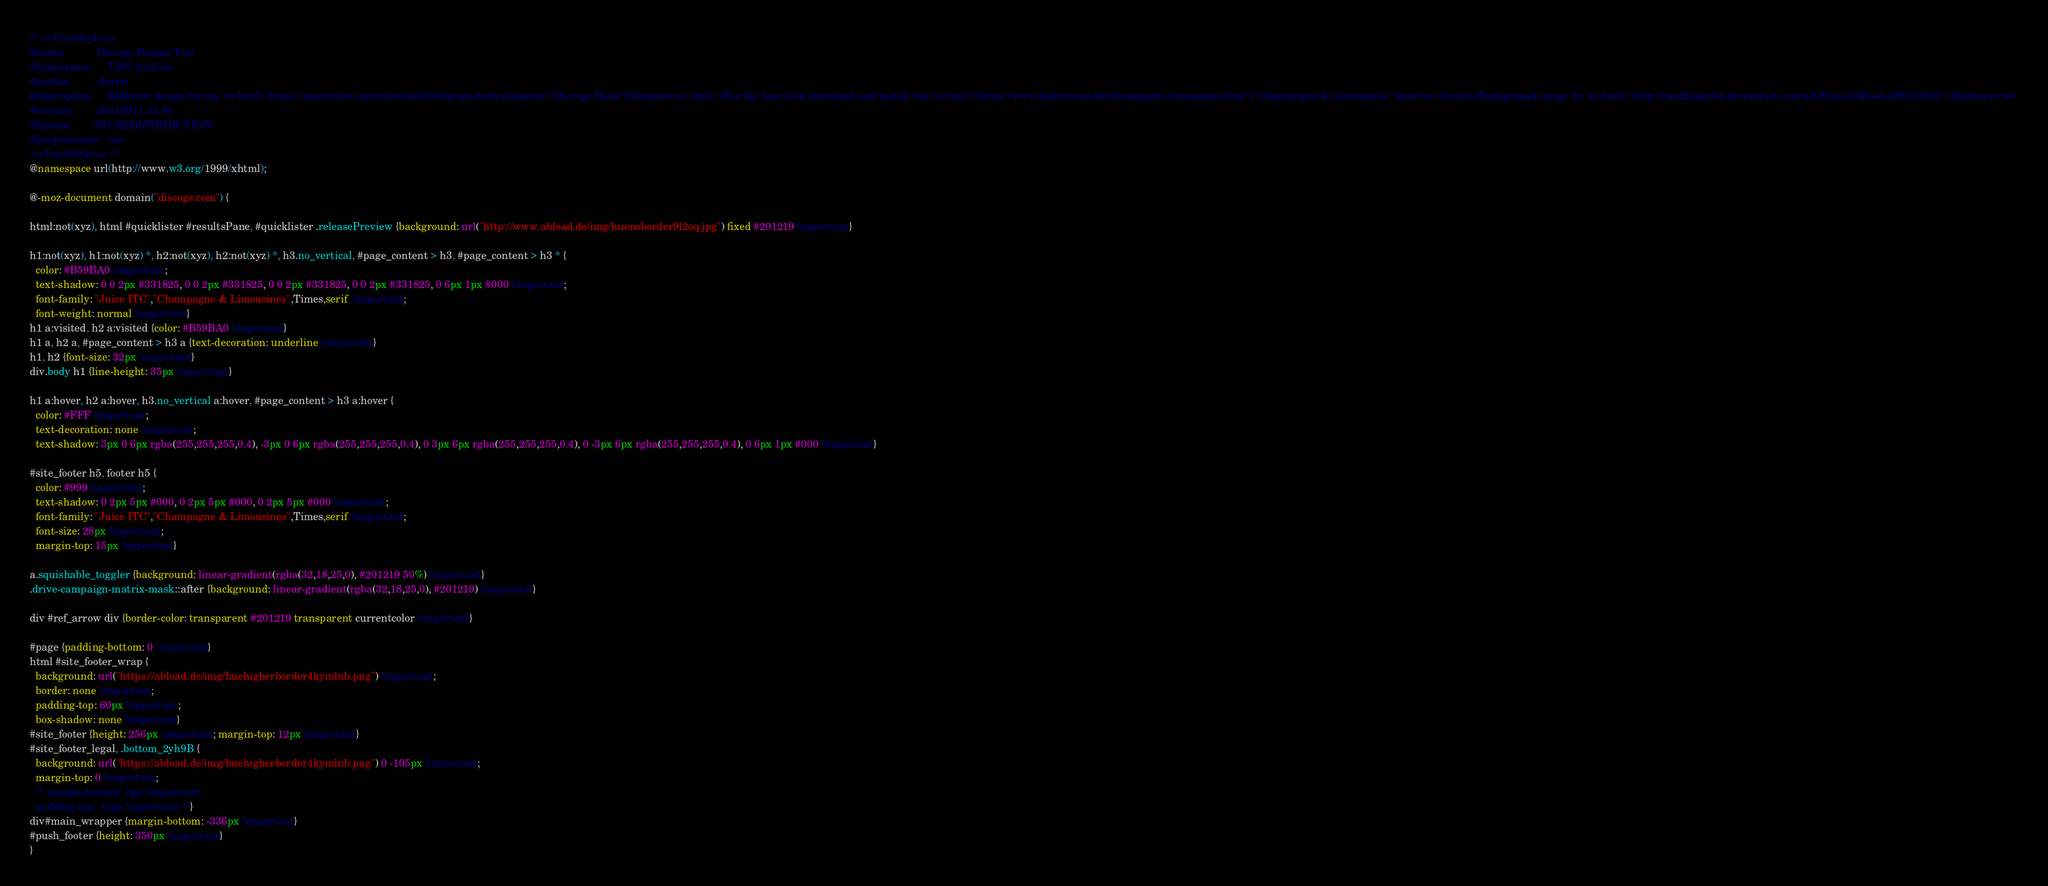<code> <loc_0><loc_0><loc_500><loc_500><_CSS_>/* ==UserStyle==
@name           Discogs Design Test
@namespace      USO Archive
@author         stormi
@description    `Different design for my <a href="https://userstyles.org/styles/44530/discogs-dark-ultimate">Discogs Dark Ultimate</a> style :)For the best look download and install the <a href="https://www.dafont.com/de/champagne-limousines.font">"Champagne & Limousines" font</a> Credits:Background image by <a href="http://vanillasky84.deviantart.com/art/Hue-of-Blood-268118623">Zurbaua</a>`
@version        20210911.13.48
@license        NO-REDISTRIBUTION
@preprocessor   uso
==/UserStyle== */
@namespace url(http://www.w3.org/1999/xhtml);

@-moz-document domain("discogs.com") {

html:not(xyz), html #quicklister #resultsPane, #quicklister .releasePreview {background: url("http://www.abload.de/img/huenoborder9l2oq.jpg") fixed #201219 !important}

h1:not(xyz), h1:not(xyz) *, h2:not(xyz), h2:not(xyz) *, h3.no_vertical, #page_content > h3, #page_content > h3 * {
  color: #B59BA0 !important;
  text-shadow: 0 0 2px #331825, 0 0 2px #331825, 0 0 2px #331825, 0 0 2px #331825, 0 6px 1px #000 !important;
  font-family: "Juice ITC","Champagne & Limousines",Times,serif !important;
  font-weight: normal !important}
h1 a:visited, h2 a:visited {color: #B59BA0 !important}
h1 a, h2 a, #page_content > h3 a {text-decoration: underline !important}
h1, h2 {font-size: 32px !important}
div.body h1 {line-height: 35px !important}

h1 a:hover, h2 a:hover, h3.no_vertical a:hover, #page_content > h3 a:hover {
  color: #FFF !important;
  text-decoration: none !important;
  text-shadow: 3px 0 6px rgba(255,255,255,0.4), -3px 0 6px rgba(255,255,255,0.4), 0 3px 6px rgba(255,255,255,0.4), 0 -3px 6px rgba(255,255,255,0.4), 0 6px 1px #000 !important}

#site_footer h5, footer h5 {
  color: #999 !important;
  text-shadow: 0 2px 5px #000, 0 2px 5px #000, 0 2px 5px #000 !important;
  font-family: "Juice ITC","Champagne & Limousines",Times,serif !important;
  font-size: 28px !important;
  margin-top: 15px !important}

a.squishable_toggler {background: linear-gradient(rgba(32,18,25,0), #201219 50%) !important}
.drive-campaign-matrix-mask::after {background: linear-gradient(rgba(32,18,25,0), #201219) !important}

div #ref_arrow div {border-color: transparent #201219 transparent currentcolor !important}

#page {padding-bottom: 0 !important}
html #site_footer_wrap {
  background: url("https://abload.de/img/huehigherborder4kymlnb.png") !important;
  border: none !important;
  padding-top: 60px !important;
  box-shadow: none !important}
#site_footer {height: 256px !important; margin-top: 12px !important}
#site_footer_legal, .bottom_2yh9B {
  background: url("https://abload.de/img/huehigherborder4kymlnb.png") 0 -105px !important;
  margin-top: 0 !important;
  /* margin-bottom: 0px !important;
  padding-top: 12px !important */}
div#main_wrapper {margin-bottom: -336px !important}
#push_footer {height: 350px !important}
}</code> 